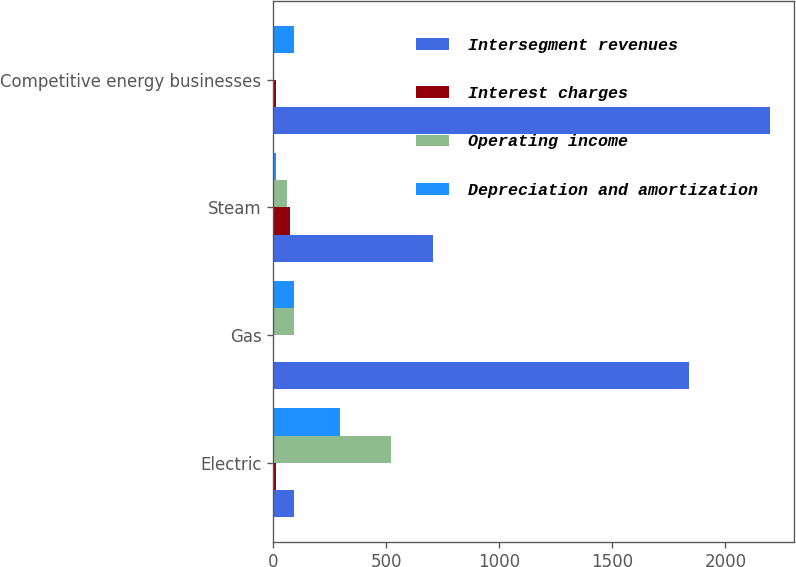<chart> <loc_0><loc_0><loc_500><loc_500><stacked_bar_chart><ecel><fcel>Electric<fcel>Gas<fcel>Steam<fcel>Competitive energy businesses<nl><fcel>Intersegment revenues<fcel>90<fcel>1839<fcel>707<fcel>2195<nl><fcel>Interest charges<fcel>12<fcel>5<fcel>74<fcel>11<nl><fcel>Operating income<fcel>521<fcel>90<fcel>61<fcel>5<nl><fcel>Depreciation and amortization<fcel>295<fcel>91<fcel>10<fcel>92<nl></chart> 